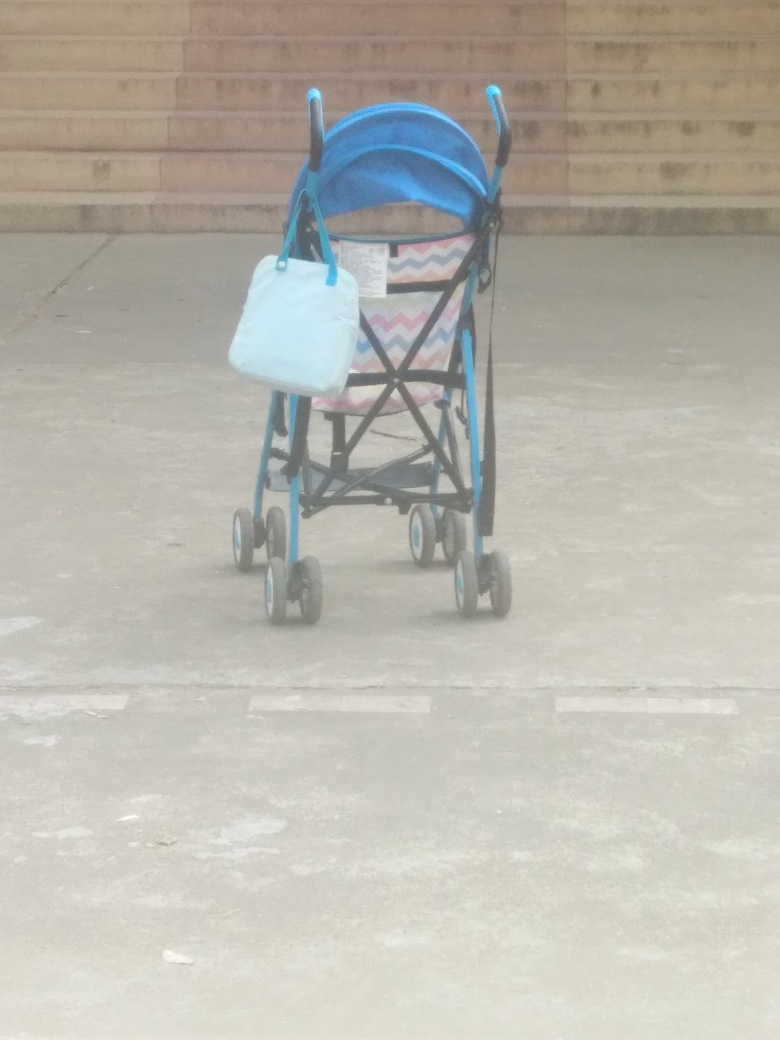Is the image quality poor? While the image is discernible, it does appear to be slightly blurred, with a softness around the edges of the objects and a lack of crispness that one would expect from a high-quality photo. This could be due to a number of factors, such as camera motion, focus issues, or atmospheric conditions if taken outdoors. However, despite these quality issues, the main subject — a stroller with a bag hanging on it — remains identifiable. 